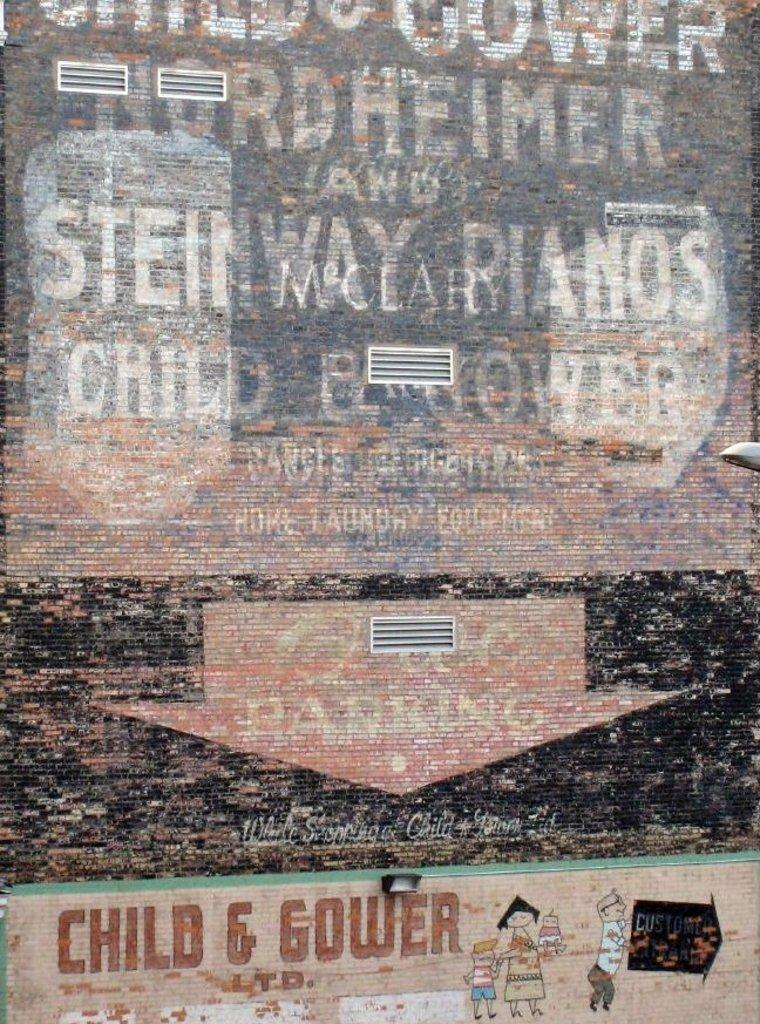Provide a one-sentence caption for the provided image. a poster for child and gower with a run down feel. 